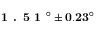<formula> <loc_0><loc_0><loc_500><loc_500>1 . 5 1 ^ { \circ } \pm 0 . 2 3 ^ { \circ }</formula> 